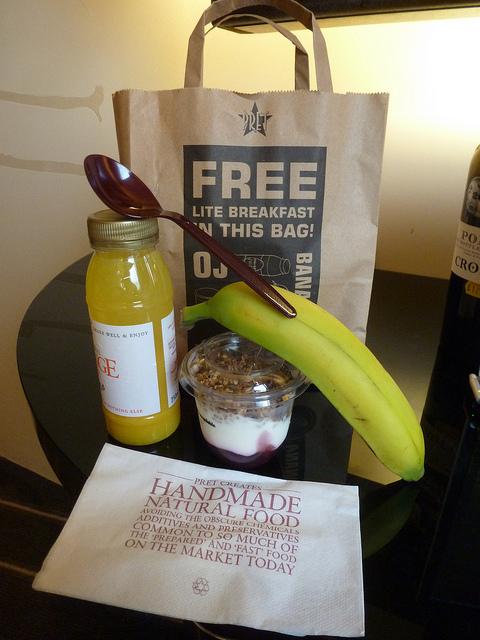Is there a knife in the picture?
Short answer required. No. Is the bottle full?
Concise answer only. Yes. How much does it cost, according to the bag?
Short answer required. Free. What does this breakfast include?
Answer briefly. Banana. Is there powdered sugar on top of the desert?
Concise answer only. No. 